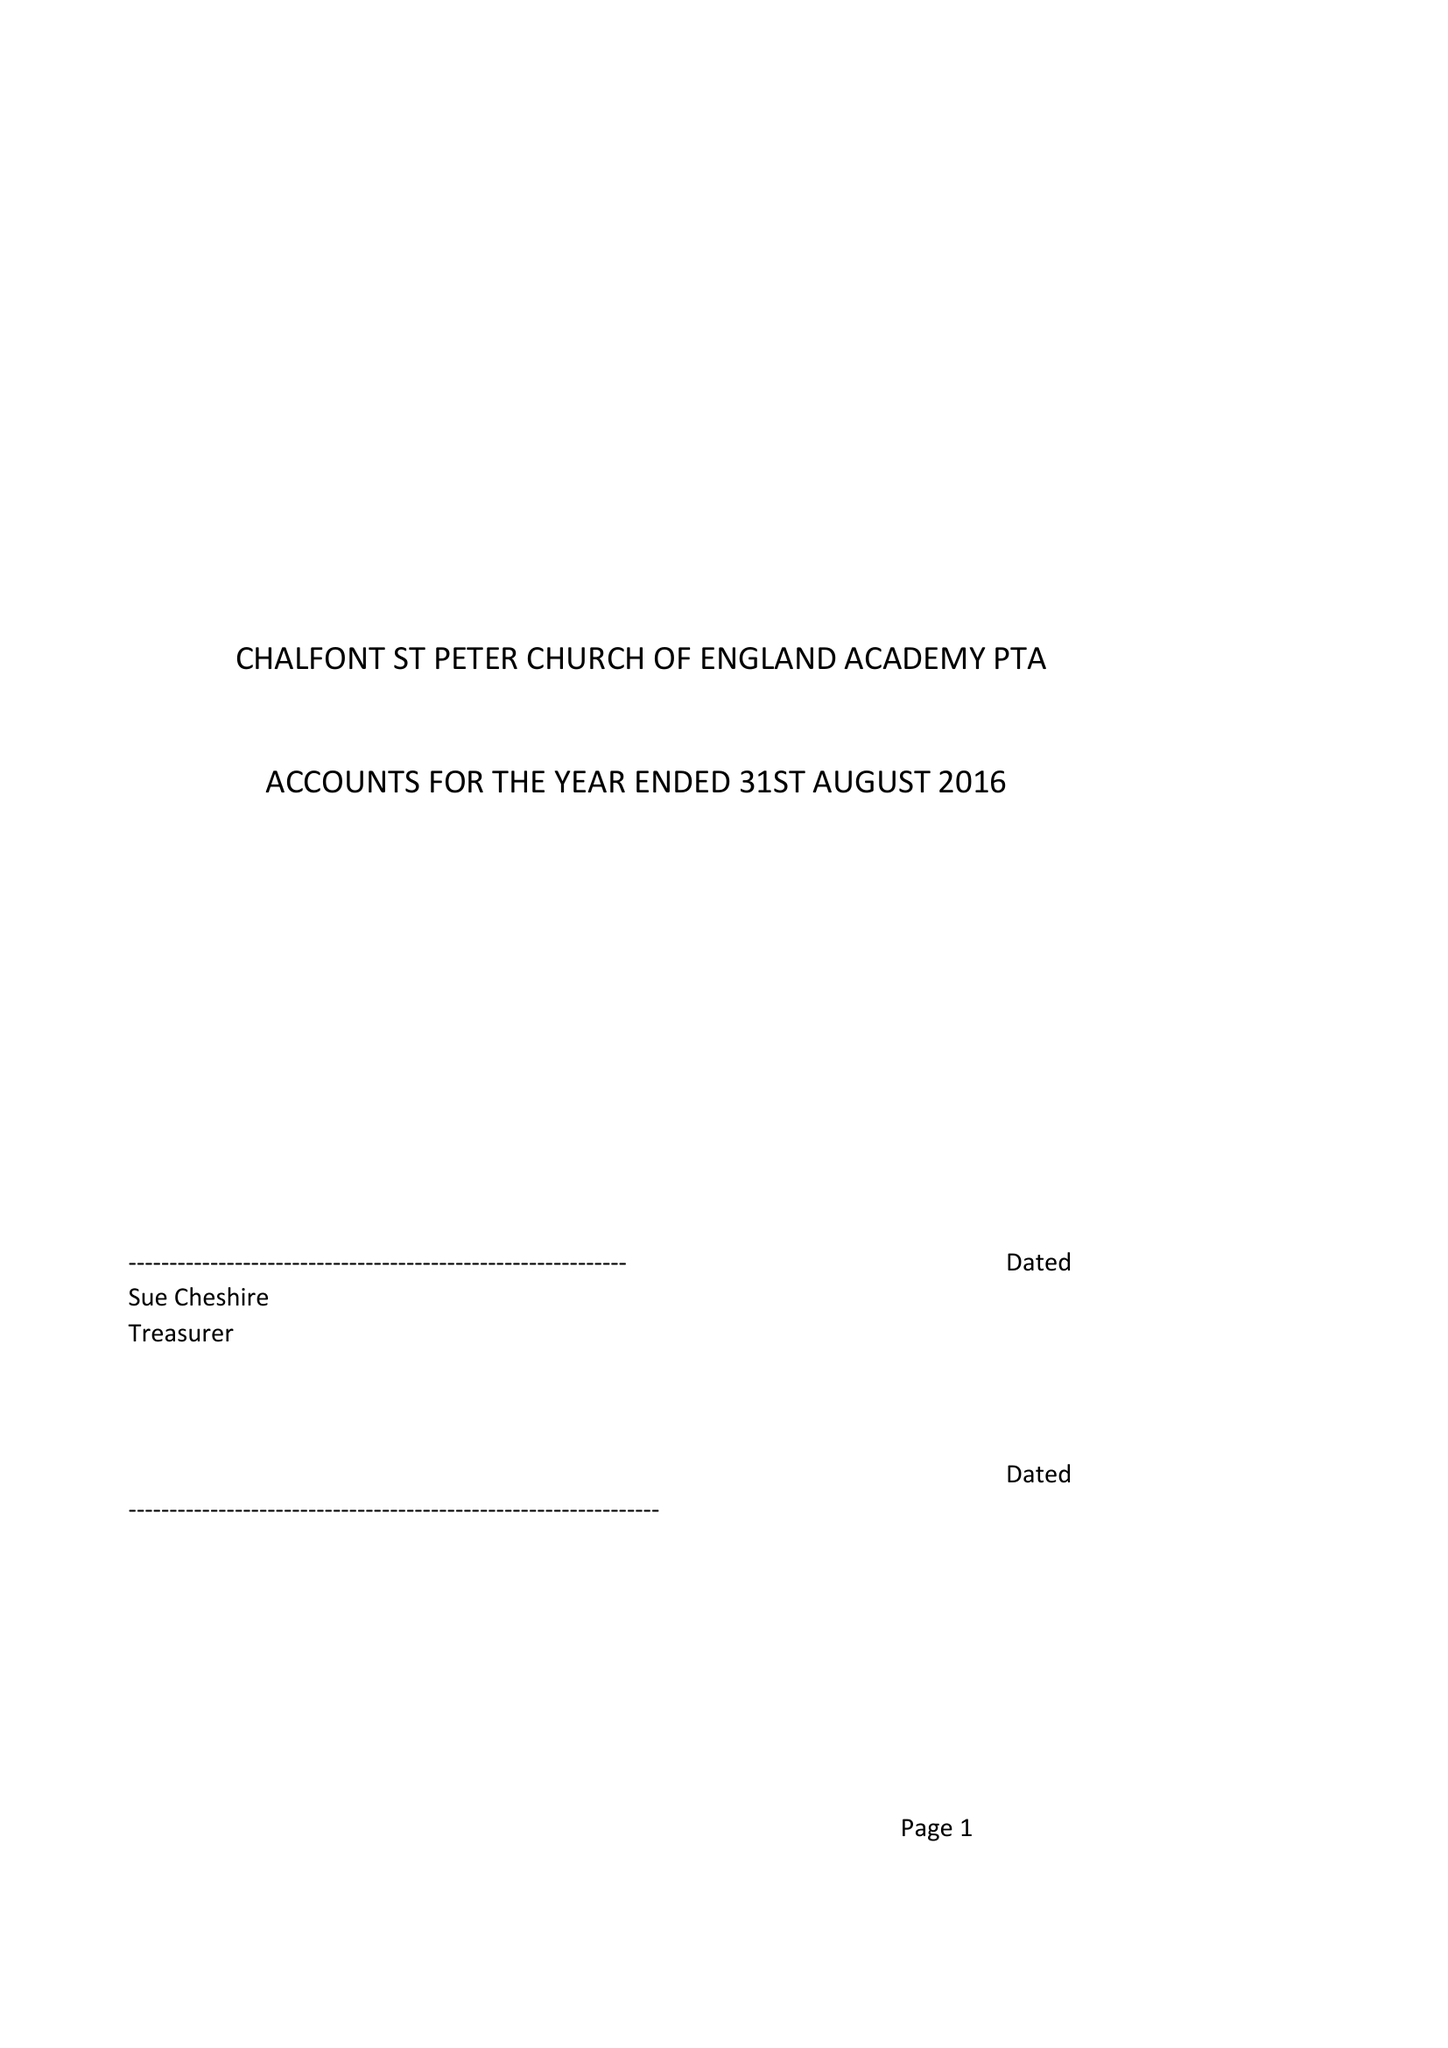What is the value for the address__postcode?
Answer the question using a single word or phrase. SL9 9SS 